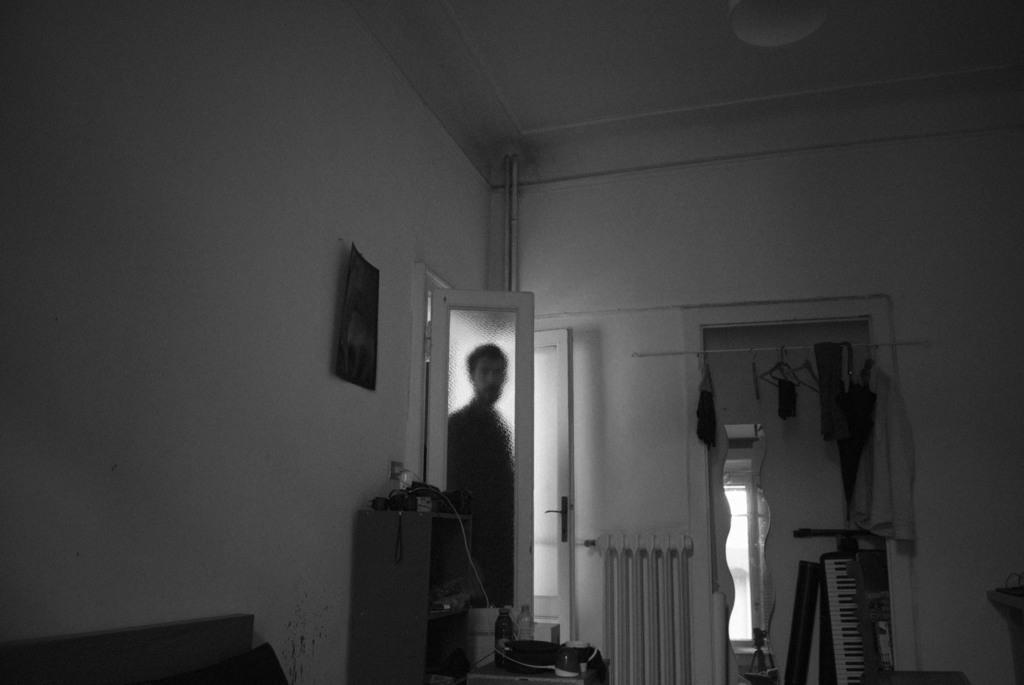Can you describe this image briefly? In this picture I can see a man is standing beside a door. In the background I can see musical instruments and other objects. On the left side I can see an object attached to the wall and a cupboard on which I can see some objects. This picture is black and white in color. 